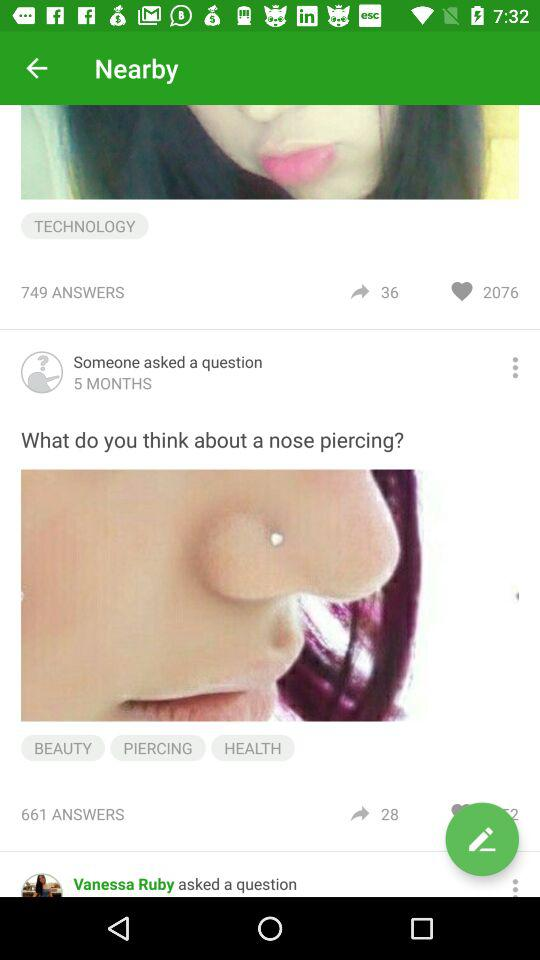How many answers in total are there for "What do you think about a nose piercing?"? There are 661 answers. 